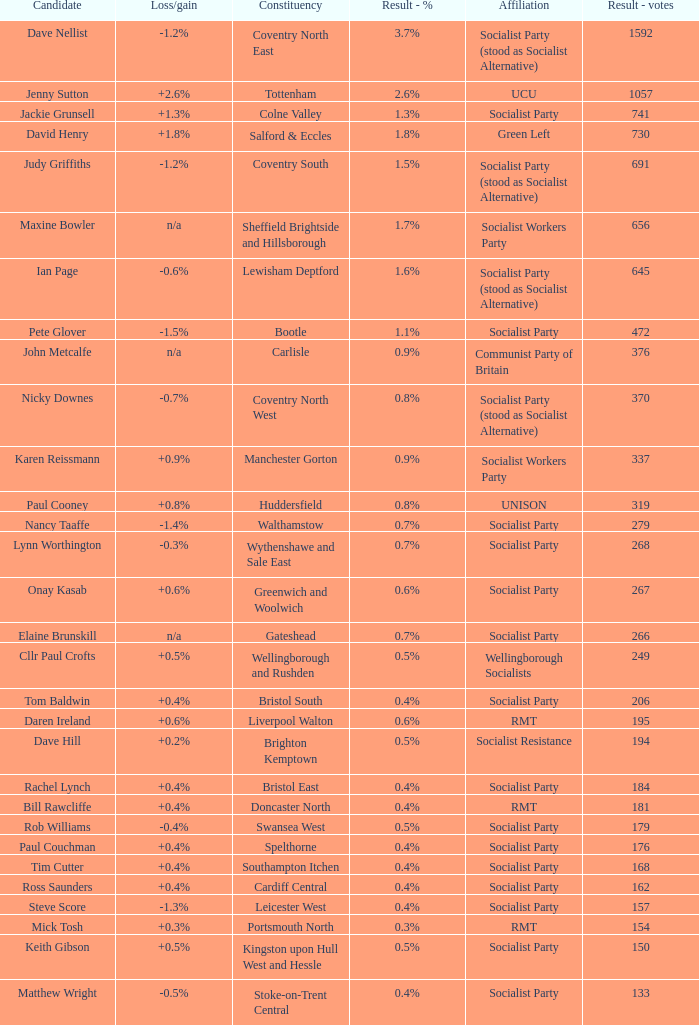Write the full table. {'header': ['Candidate', 'Loss/gain', 'Constituency', 'Result - %', 'Affiliation', 'Result - votes'], 'rows': [['Dave Nellist', '-1.2%', 'Coventry North East', '3.7%', 'Socialist Party (stood as Socialist Alternative)', '1592'], ['Jenny Sutton', '+2.6%', 'Tottenham', '2.6%', 'UCU', '1057'], ['Jackie Grunsell', '+1.3%', 'Colne Valley', '1.3%', 'Socialist Party', '741'], ['David Henry', '+1.8%', 'Salford & Eccles', '1.8%', 'Green Left', '730'], ['Judy Griffiths', '-1.2%', 'Coventry South', '1.5%', 'Socialist Party (stood as Socialist Alternative)', '691'], ['Maxine Bowler', 'n/a', 'Sheffield Brightside and Hillsborough', '1.7%', 'Socialist Workers Party', '656'], ['Ian Page', '-0.6%', 'Lewisham Deptford', '1.6%', 'Socialist Party (stood as Socialist Alternative)', '645'], ['Pete Glover', '-1.5%', 'Bootle', '1.1%', 'Socialist Party', '472'], ['John Metcalfe', 'n/a', 'Carlisle', '0.9%', 'Communist Party of Britain', '376'], ['Nicky Downes', '-0.7%', 'Coventry North West', '0.8%', 'Socialist Party (stood as Socialist Alternative)', '370'], ['Karen Reissmann', '+0.9%', 'Manchester Gorton', '0.9%', 'Socialist Workers Party', '337'], ['Paul Cooney', '+0.8%', 'Huddersfield', '0.8%', 'UNISON', '319'], ['Nancy Taaffe', '-1.4%', 'Walthamstow', '0.7%', 'Socialist Party', '279'], ['Lynn Worthington', '-0.3%', 'Wythenshawe and Sale East', '0.7%', 'Socialist Party', '268'], ['Onay Kasab', '+0.6%', 'Greenwich and Woolwich', '0.6%', 'Socialist Party', '267'], ['Elaine Brunskill', 'n/a', 'Gateshead', '0.7%', 'Socialist Party', '266'], ['Cllr Paul Crofts', '+0.5%', 'Wellingborough and Rushden', '0.5%', 'Wellingborough Socialists', '249'], ['Tom Baldwin', '+0.4%', 'Bristol South', '0.4%', 'Socialist Party', '206'], ['Daren Ireland', '+0.6%', 'Liverpool Walton', '0.6%', 'RMT', '195'], ['Dave Hill', '+0.2%', 'Brighton Kemptown', '0.5%', 'Socialist Resistance', '194'], ['Rachel Lynch', '+0.4%', 'Bristol East', '0.4%', 'Socialist Party', '184'], ['Bill Rawcliffe', '+0.4%', 'Doncaster North', '0.4%', 'RMT', '181'], ['Rob Williams', '-0.4%', 'Swansea West', '0.5%', 'Socialist Party', '179'], ['Paul Couchman', '+0.4%', 'Spelthorne', '0.4%', 'Socialist Party', '176'], ['Tim Cutter', '+0.4%', 'Southampton Itchen', '0.4%', 'Socialist Party', '168'], ['Ross Saunders', '+0.4%', 'Cardiff Central', '0.4%', 'Socialist Party', '162'], ['Steve Score', '-1.3%', 'Leicester West', '0.4%', 'Socialist Party', '157'], ['Mick Tosh', '+0.3%', 'Portsmouth North', '0.3%', 'RMT', '154'], ['Keith Gibson', '+0.5%', 'Kingston upon Hull West and Hessle', '0.5%', 'Socialist Party', '150'], ['Matthew Wright', '-0.5%', 'Stoke-on-Trent Central', '0.4%', 'Socialist Party', '133']]} What is the largest vote result for the Huddersfield constituency? 319.0. 